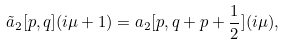Convert formula to latex. <formula><loc_0><loc_0><loc_500><loc_500>\tilde { a } _ { 2 } [ p , q ] ( i \mu + 1 ) = a _ { 2 } [ p , q + p + \frac { 1 } { 2 } ] ( i \mu ) ,</formula> 